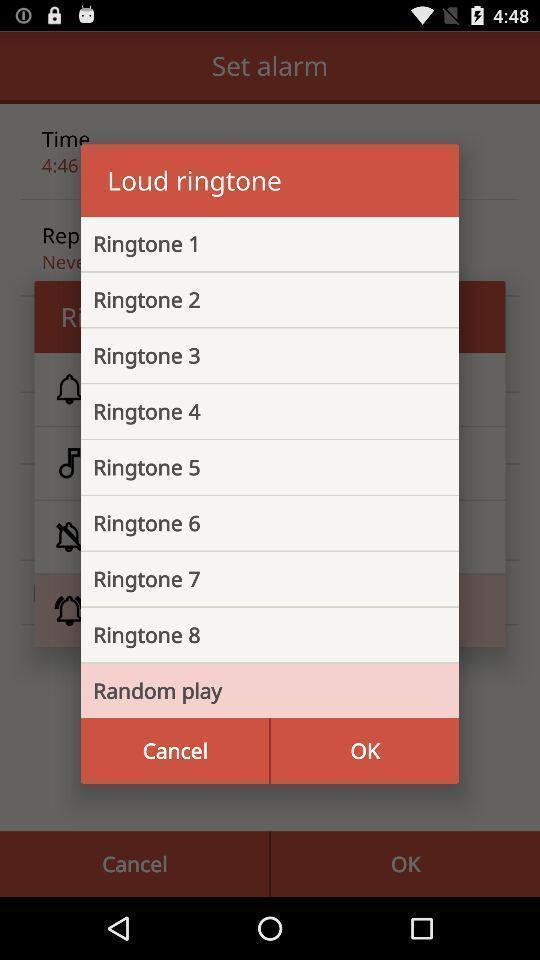Give me a summary of this screen capture. Pop-up shows list of loud ringtones. 